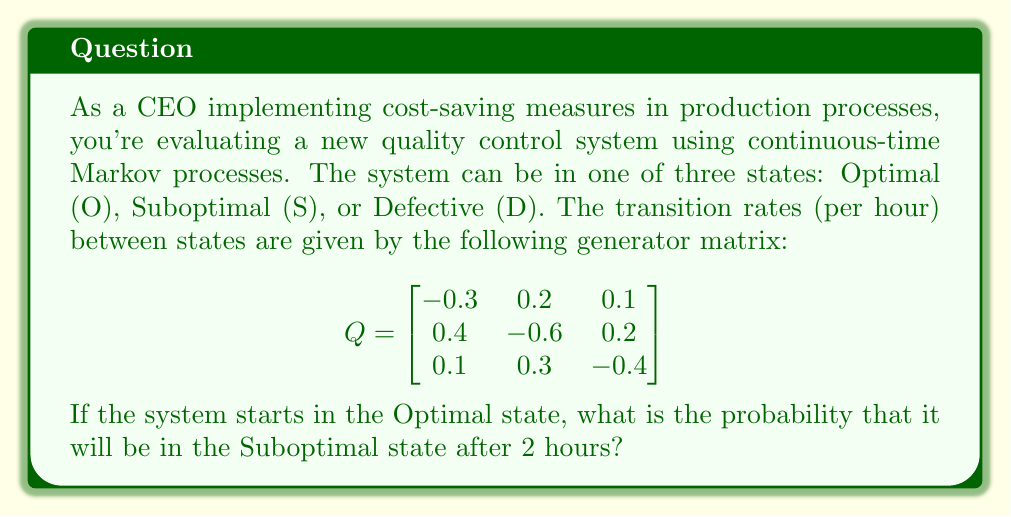Can you solve this math problem? To solve this problem, we need to use the continuous-time Markov chain transition probability formula:

$$P(t) = e^{Qt}$$

Where $P(t)$ is the transition probability matrix at time $t$, $Q$ is the generator matrix, and $e$ is the matrix exponential.

Steps to solve:

1) First, we need to calculate $e^{Qt}$. For $t = 2$ hours, we have:

   $$e^{2Q} = e^{2 \begin{bmatrix}
   -0.3 & 0.2 & 0.1 \\
   0.4 & -0.6 & 0.2 \\
   0.1 & 0.3 & -0.4
   \end{bmatrix}}$$

2) Calculating the matrix exponential is complex, so we'll use a numerical method or software to compute it. The result is approximately:

   $$e^{2Q} \approx \begin{bmatrix}
   0.5777 & 0.2830 & 0.1393 \\
   0.4717 & 0.3585 & 0.1698 \\
   0.2264 & 0.3396 & 0.4340
   \end{bmatrix}$$

3) The probability of transitioning from the Optimal state (O) to the Suboptimal state (S) after 2 hours is given by the element in the first row, second column of this matrix.

4) Therefore, the probability is approximately 0.2830 or 28.30%.
Answer: 0.2830 (or 28.30%) 